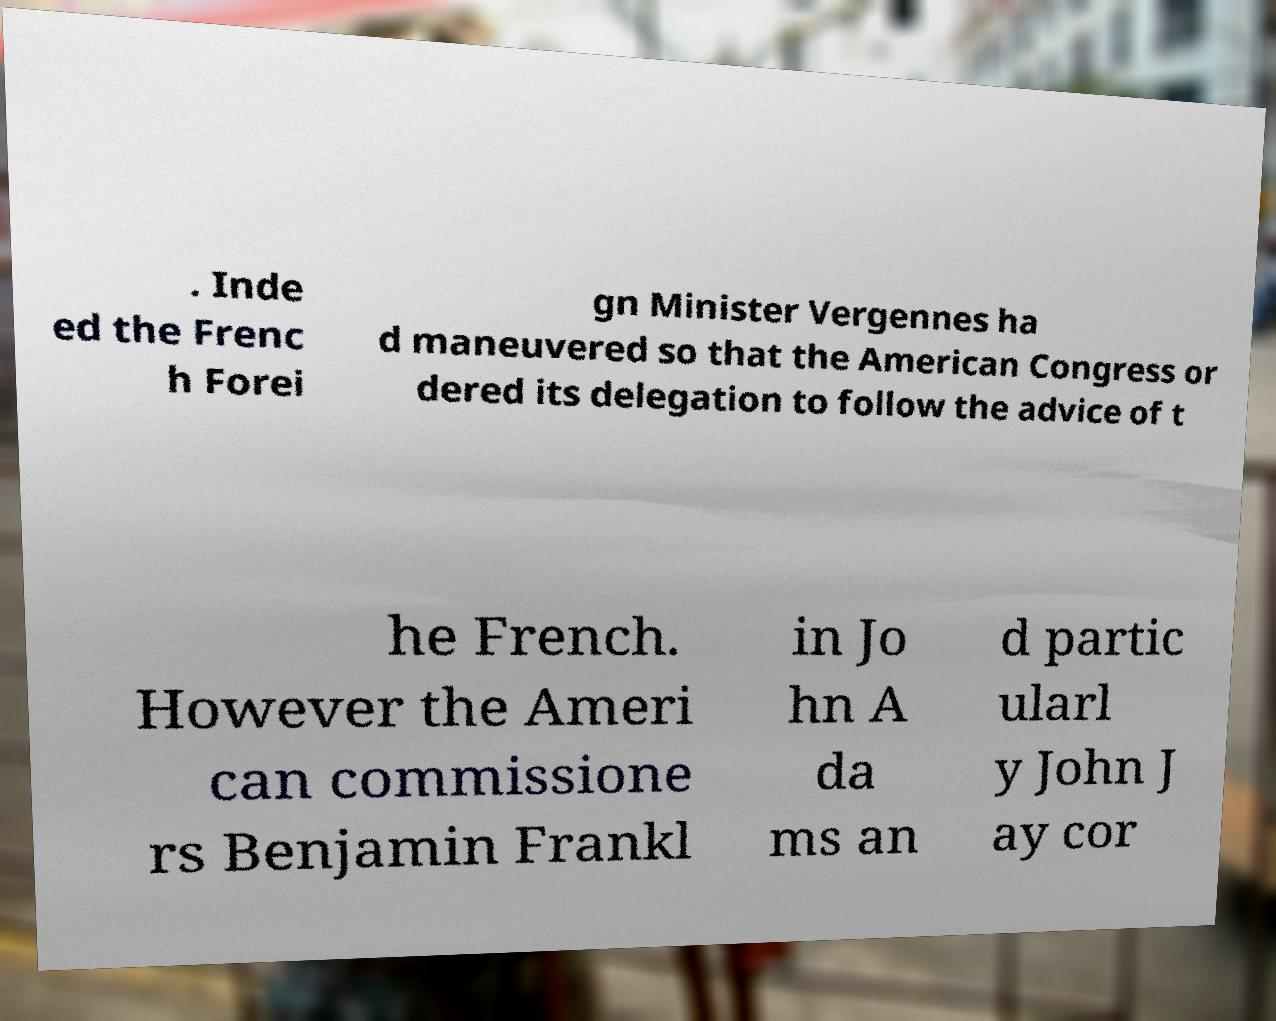Please read and relay the text visible in this image. What does it say? . Inde ed the Frenc h Forei gn Minister Vergennes ha d maneuvered so that the American Congress or dered its delegation to follow the advice of t he French. However the Ameri can commissione rs Benjamin Frankl in Jo hn A da ms an d partic ularl y John J ay cor 